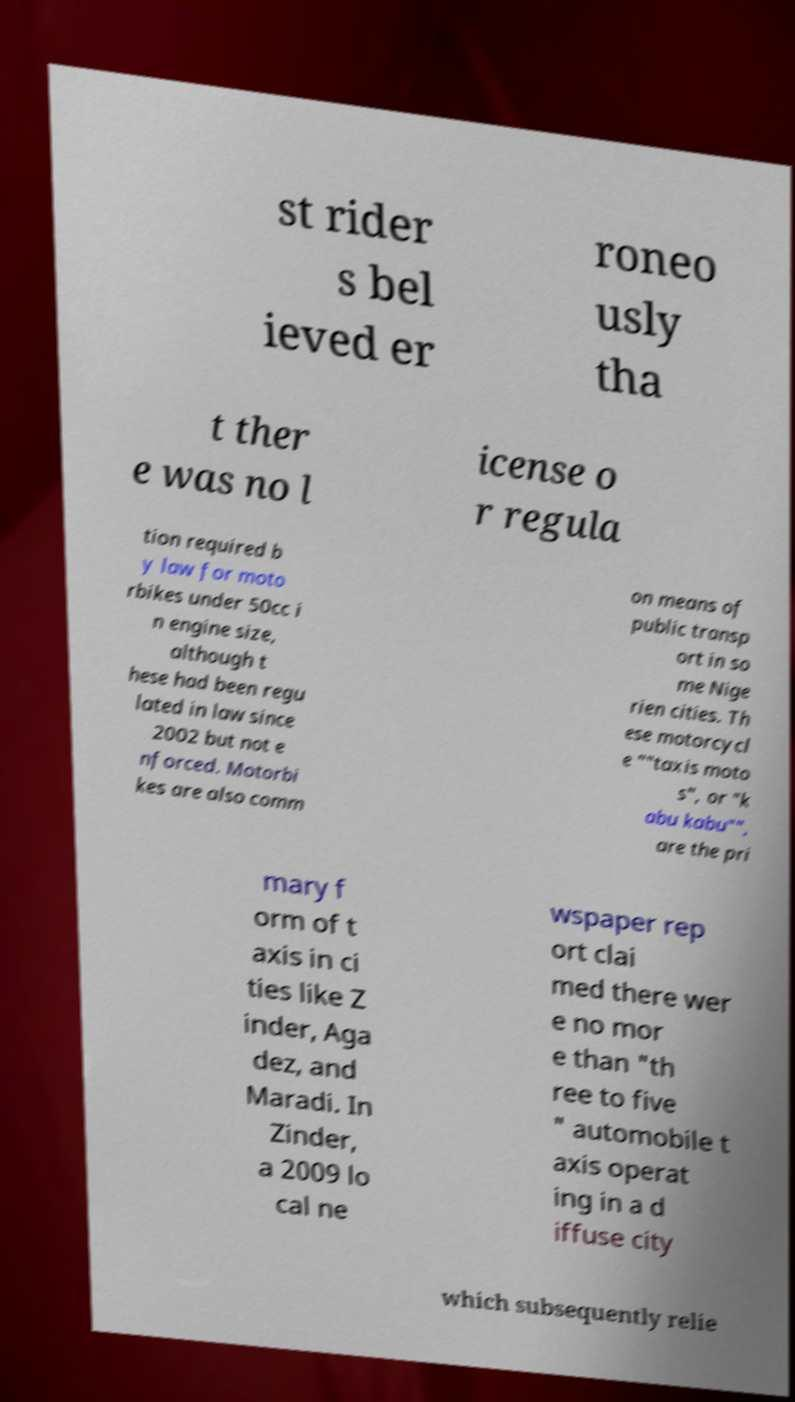For documentation purposes, I need the text within this image transcribed. Could you provide that? st rider s bel ieved er roneo usly tha t ther e was no l icense o r regula tion required b y law for moto rbikes under 50cc i n engine size, although t hese had been regu lated in law since 2002 but not e nforced. Motorbi kes are also comm on means of public transp ort in so me Nige rien cities. Th ese motorcycl e ""taxis moto s", or "k abu kabu"", are the pri mary f orm of t axis in ci ties like Z inder, Aga dez, and Maradi. In Zinder, a 2009 lo cal ne wspaper rep ort clai med there wer e no mor e than "th ree to five " automobile t axis operat ing in a d iffuse city which subsequently relie 